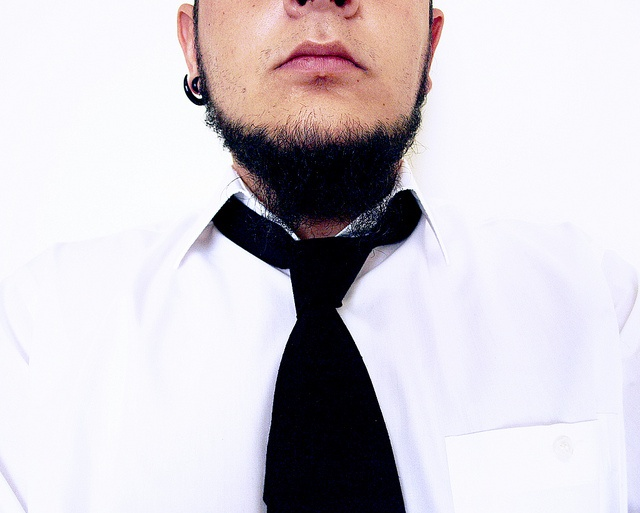Describe the objects in this image and their specific colors. I can see people in white, black, and tan tones and tie in white, black, navy, darkgray, and gray tones in this image. 